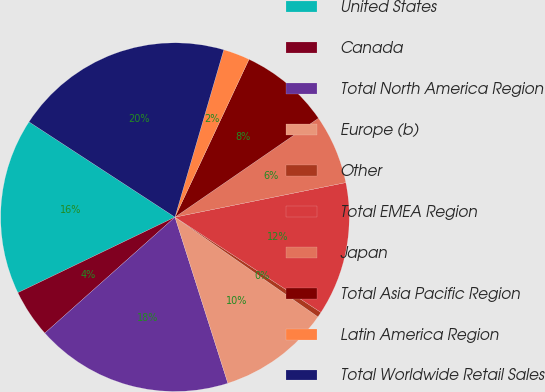Convert chart. <chart><loc_0><loc_0><loc_500><loc_500><pie_chart><fcel>United States<fcel>Canada<fcel>Total North America Region<fcel>Europe (b)<fcel>Other<fcel>Total EMEA Region<fcel>Japan<fcel>Total Asia Pacific Region<fcel>Latin America Region<fcel>Total Worldwide Retail Sales<nl><fcel>16.34%<fcel>4.45%<fcel>18.32%<fcel>10.4%<fcel>0.49%<fcel>12.38%<fcel>6.43%<fcel>8.41%<fcel>2.47%<fcel>20.31%<nl></chart> 